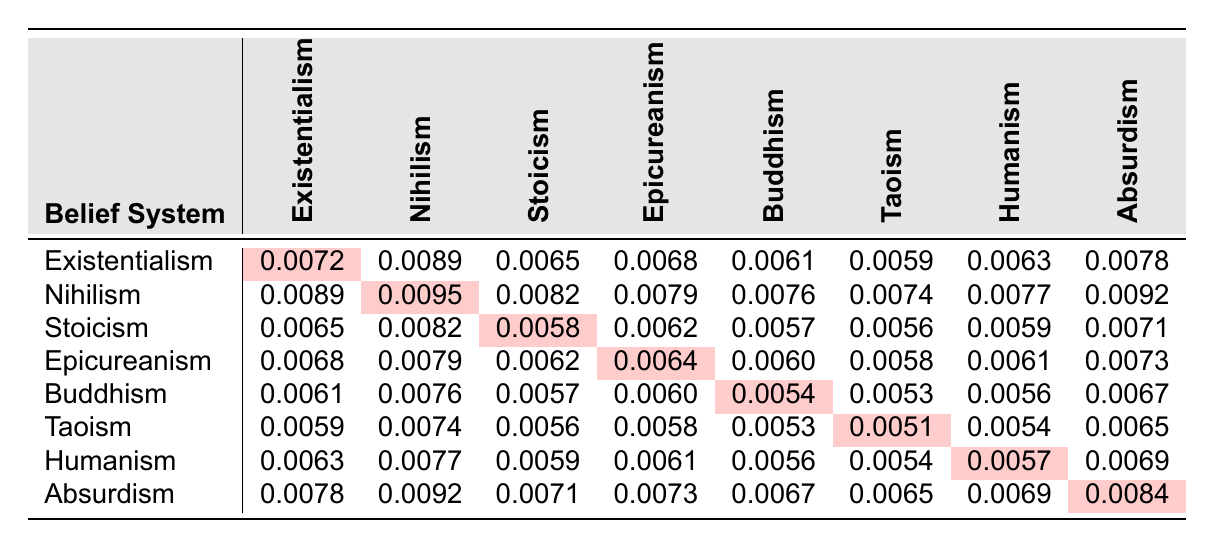What is the mortality rate associated with Stoicism when compared to Absurdism? The mortality rate for Stoicism is 0.0058 and for Absurdism, it is 0.0084. Comparing these values shows that Stoicism has a lower mortality rate.
Answer: Lower What is the highest mortality rate recorded in this table? Scanning through the table, the highest mortality rate is found in Nihilism at 0.0095.
Answer: 0.0095 Which belief system has the lowest mortality rate? By examining the values, Taoism has the lowest mortality rate at 0.0051.
Answer: 0.0051 Is the mortality rate for Buddhism higher than that for Humanism? The rate for Buddhism is 0.0054 and for Humanism is 0.0057. Since 0.0054 is less than 0.0057, the statement is false.
Answer: No What is the average mortality rate for Existentialism? The rates are 0.0072, 0.0089, 0.0065, 0.0068, 0.0061, 0.0059, 0.0063, and 0.0078. Summing these values gives 0.0072 + 0.0089 + 0.0065 + 0.0068 + 0.0061 + 0.0059 + 0.0063 + 0.0078 = 0.0575; dividing by 8 gives an average of 0.0575 / 8 = 0.0071875, rounded to four decimal places results in approximately 0.0072.
Answer: 0.0072 What is the difference between the mortality rates of Epicureanism and Buddhism? The mortality rate for Epicureanism is 0.0064 and for Buddhism, it is 0.0054. The difference is calculated by 0.0064 - 0.0054, which equals 0.001.
Answer: 0.001 Which belief system combinations have mortality rates that add up to more than 0.015? By considering pairs like Nihilism (0.0095) and Absurdism (0.0084), their sum is 0.0095 + 0.0084 = 0.0179, which is greater than 0.015. Additionally, Existentialism (0.0072) and Nihilism (0.0095) also sum to 0.0167, which is greater than 0.015.
Answer: Existentialism & Nihilism, Nihilism & Absurdism What is the mortality rate correlation between Taoism and Humanism? The mortality rate for Taoism is 0.0051 and for Humanism is 0.0057. Both rates are relatively close, but strict numerical correlation isn't discernible from the table, indicating they are statistically similar without a direct correlation coefficient calculation.
Answer: Close and similar How does the mortality rate of Stoicism compare to the average of the other belief systems? The average of the other systems is (0.0089 + 0.0082 + 0.0062 + 0.0060 + 0.0053 + 0.0063 + 0.0071)/(7)=0.0072. Stoicism has a mortality rate of 0.0058, which is lower than this average, indicating Stoicism's beliefs associate with a better mortality outcome.
Answer: Lower than average 